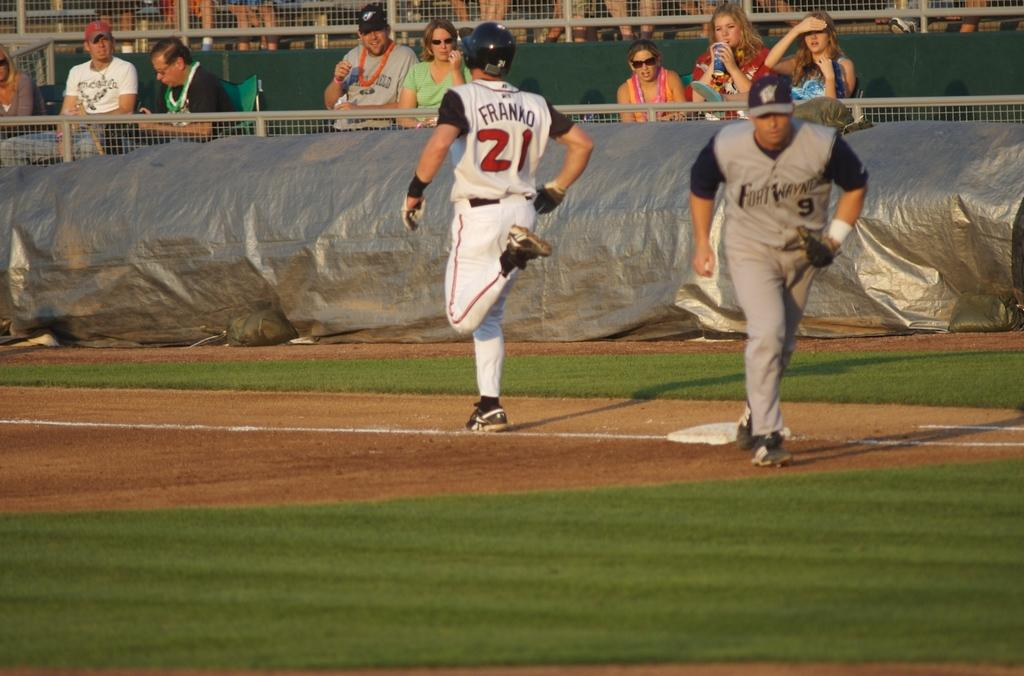<image>
Provide a brief description of the given image. Baseball player Franko is running for a base. 